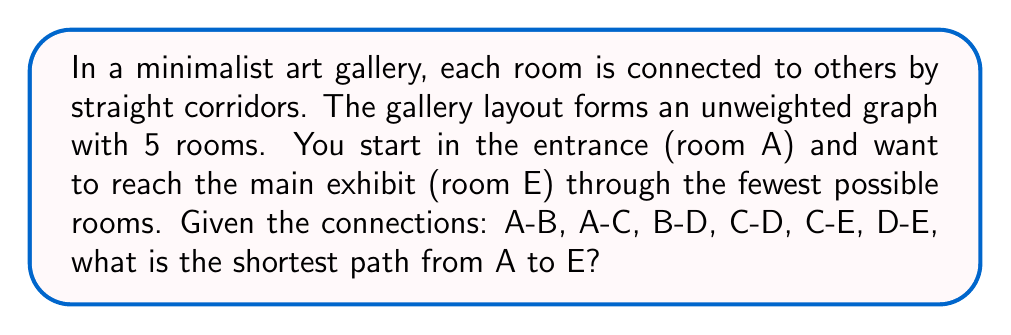Give your solution to this math problem. To find the shortest path in this unweighted graph, we'll use breadth-first search (BFS). This method is ideal for its simplicity and efficiency, aligning with minimalist principles.

Steps:
1. Start at room A (the root node).
2. Explore immediate neighbors: B and C.
3. Since C is connected to E, we've found the shortest path.

Mathematically, we can represent this process as follows:

Let $G = (V, E)$ be our graph where:
$V = \{A, B, C, D, E\}$
$E = \{(A,B), (A,C), (B,D), (C,D), (C,E), (D,E)\}$

BFS explores in levels:
Level 0: $\{A\}$
Level 1: $\{B, C\}$
Level 2: $\{D, E\}$

The shortest path is found when E is first encountered, which occurs at level 2 through C.

[asy]
unitsize(30);
pair A = (0,0), B = (-1,-1), C = (1,-1), D = (0,-2), E = (2,-2);
dot(A); dot(B); dot(C); dot(D); dot(E);
draw(A--B--D--E);
draw(A--C--D);
draw(C--E);
label("A", A, N);
label("B", B, W);
label("C", C, E);
label("D", D, S);
label("E", E, E);
[/asy]
Answer: The shortest path from A to E is A-C-E, with a length of 2 edges. 